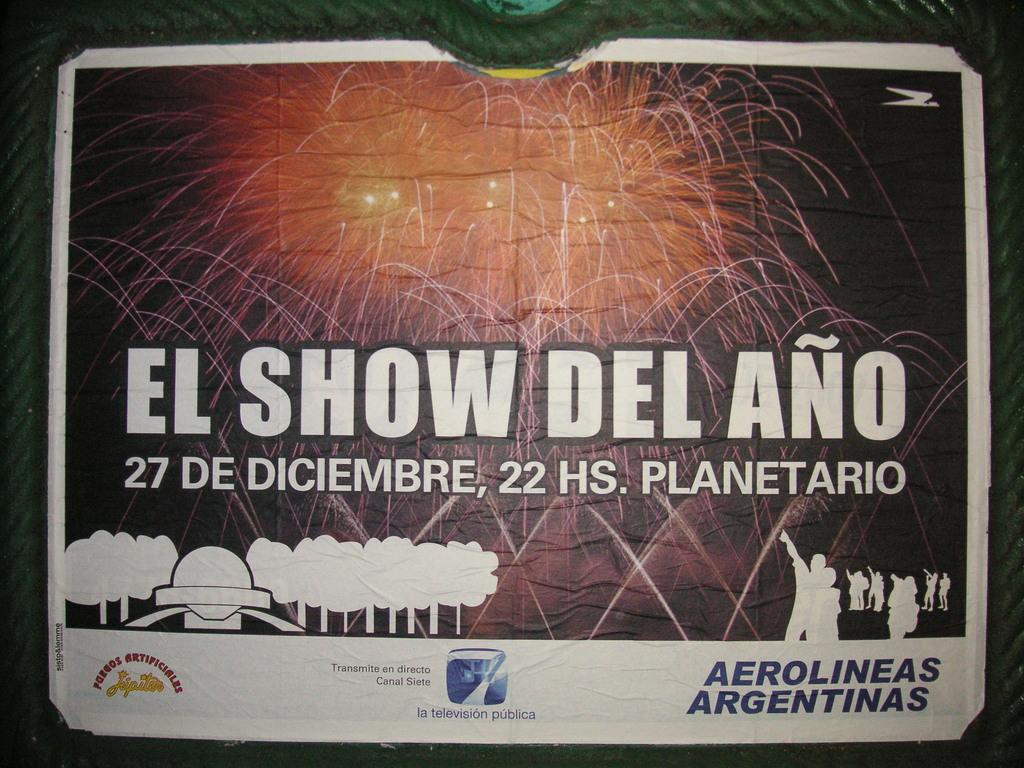<image>
Write a terse but informative summary of the picture. an advertisement for el show del ano and fireworks 